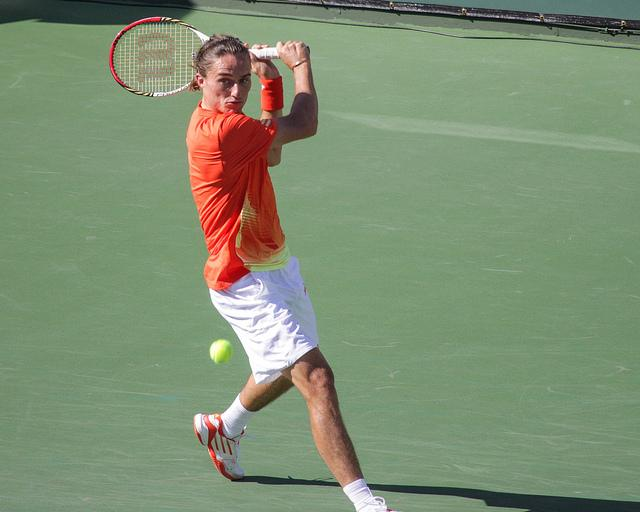Why is the man holding the racket back?

Choices:
A) to itch
B) to swing
C) to drop
D) to block to swing 